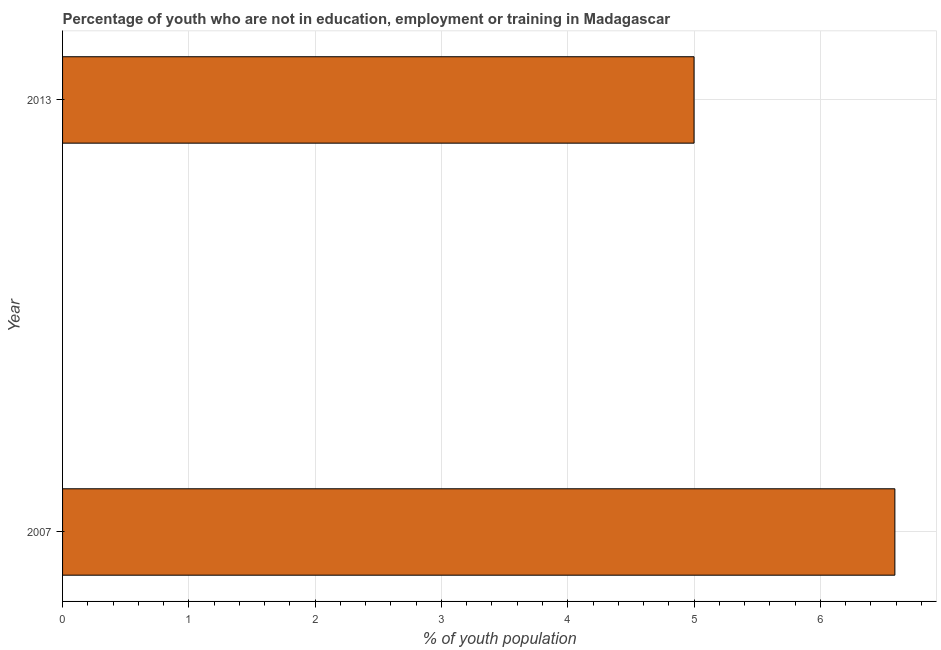Does the graph contain grids?
Offer a very short reply. Yes. What is the title of the graph?
Make the answer very short. Percentage of youth who are not in education, employment or training in Madagascar. What is the label or title of the X-axis?
Ensure brevity in your answer.  % of youth population. What is the unemployed youth population in 2013?
Offer a terse response. 5. Across all years, what is the maximum unemployed youth population?
Give a very brief answer. 6.59. In which year was the unemployed youth population maximum?
Your response must be concise. 2007. In which year was the unemployed youth population minimum?
Provide a short and direct response. 2013. What is the sum of the unemployed youth population?
Your response must be concise. 11.59. What is the difference between the unemployed youth population in 2007 and 2013?
Your response must be concise. 1.59. What is the average unemployed youth population per year?
Your answer should be very brief. 5.79. What is the median unemployed youth population?
Make the answer very short. 5.8. Do a majority of the years between 2007 and 2013 (inclusive) have unemployed youth population greater than 0.8 %?
Your response must be concise. Yes. What is the ratio of the unemployed youth population in 2007 to that in 2013?
Provide a short and direct response. 1.32. Are all the bars in the graph horizontal?
Make the answer very short. Yes. What is the difference between two consecutive major ticks on the X-axis?
Offer a terse response. 1. Are the values on the major ticks of X-axis written in scientific E-notation?
Provide a short and direct response. No. What is the % of youth population of 2007?
Make the answer very short. 6.59. What is the difference between the % of youth population in 2007 and 2013?
Ensure brevity in your answer.  1.59. What is the ratio of the % of youth population in 2007 to that in 2013?
Give a very brief answer. 1.32. 